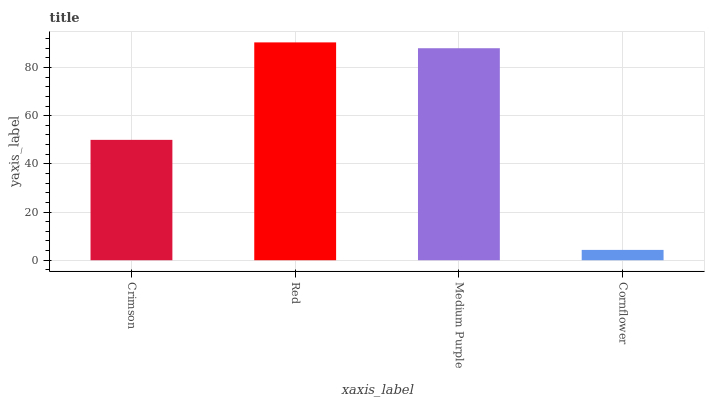Is Medium Purple the minimum?
Answer yes or no. No. Is Medium Purple the maximum?
Answer yes or no. No. Is Red greater than Medium Purple?
Answer yes or no. Yes. Is Medium Purple less than Red?
Answer yes or no. Yes. Is Medium Purple greater than Red?
Answer yes or no. No. Is Red less than Medium Purple?
Answer yes or no. No. Is Medium Purple the high median?
Answer yes or no. Yes. Is Crimson the low median?
Answer yes or no. Yes. Is Cornflower the high median?
Answer yes or no. No. Is Cornflower the low median?
Answer yes or no. No. 